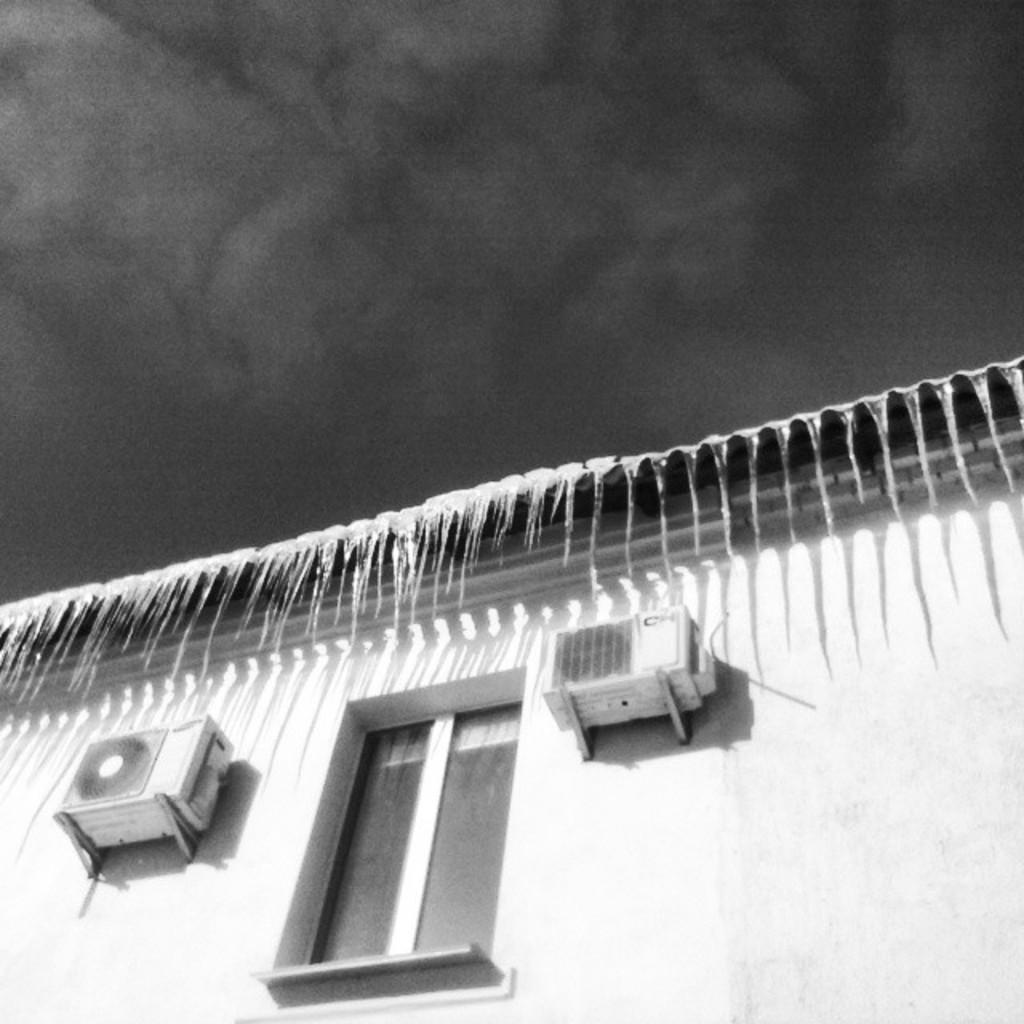What is the color scheme of the image? The image is black and white. What type of structure is visible in the image? There is a building in the image. Are there any specific features of the building that can be observed? Yes, the building has a window. Reasoning: Let's think step by step by step in order to produce the conversation. We start by identifying the color scheme of the image, which is black and white. Then, we focus on the main subject in the image, which is the building. Finally, we describe a specific feature of the building, which is the window. Each question is designed to the point and can be answered definitively with the information given. Absurd Question/Answer: What type of plate is being used to hold the neck and arm in the image? There is no plate, neck, or arm present in the image; it only features a black and white building with a window. 